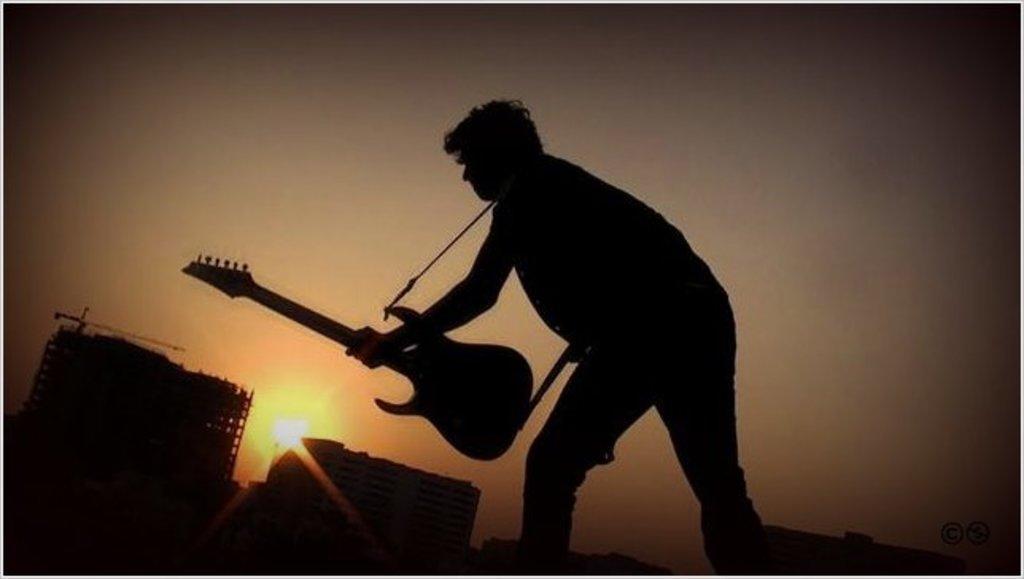In one or two sentences, can you explain what this image depicts? A man is standing by holding a guitar and here is a light and a sky. 